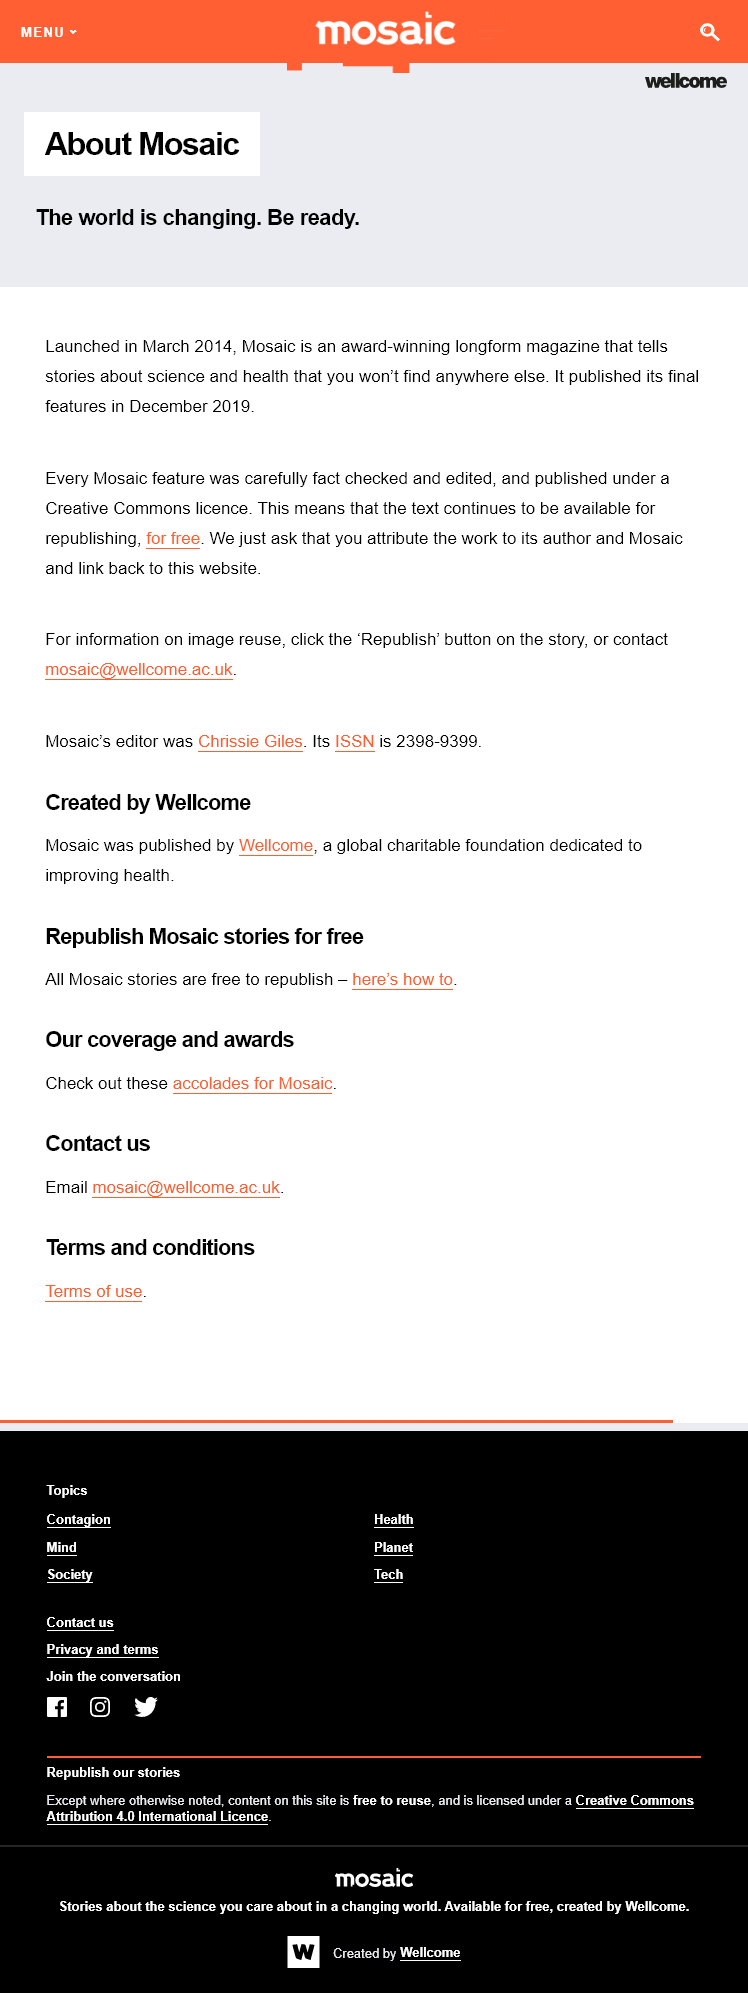Indicate a few pertinent items in this graphic. Mosaic published its final features in December 2019. Mosaic is an acclaimed magazine that features in-depth stories on science and health that are unique and unavailable elsewhere. Chrissie Giles was the editor of Mosaic. 